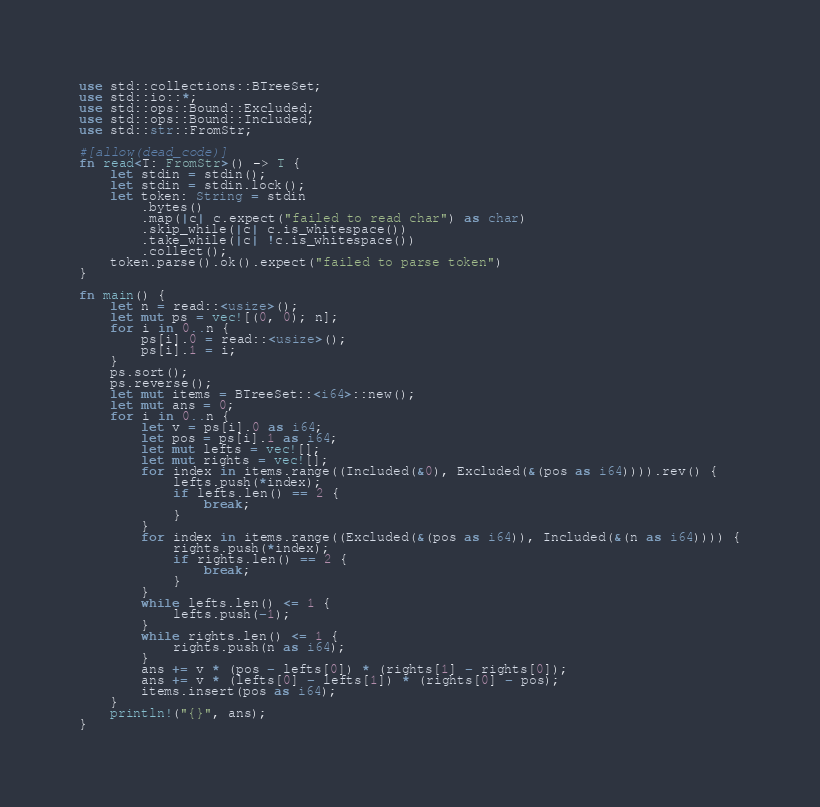Convert code to text. <code><loc_0><loc_0><loc_500><loc_500><_Rust_>use std::collections::BTreeSet;
use std::io::*;
use std::ops::Bound::Excluded;
use std::ops::Bound::Included;
use std::str::FromStr;

#[allow(dead_code)]
fn read<T: FromStr>() -> T {
    let stdin = stdin();
    let stdin = stdin.lock();
    let token: String = stdin
        .bytes()
        .map(|c| c.expect("failed to read char") as char)
        .skip_while(|c| c.is_whitespace())
        .take_while(|c| !c.is_whitespace())
        .collect();
    token.parse().ok().expect("failed to parse token")
}

fn main() {
    let n = read::<usize>();
    let mut ps = vec![(0, 0); n];
    for i in 0..n {
        ps[i].0 = read::<usize>();
        ps[i].1 = i;
    }
    ps.sort();
    ps.reverse();
    let mut items = BTreeSet::<i64>::new();
    let mut ans = 0;
    for i in 0..n {
        let v = ps[i].0 as i64;
        let pos = ps[i].1 as i64;
        let mut lefts = vec![];
        let mut rights = vec![];
        for index in items.range((Included(&0), Excluded(&(pos as i64)))).rev() {
            lefts.push(*index);
            if lefts.len() == 2 {
                break;
            }
        }
        for index in items.range((Excluded(&(pos as i64)), Included(&(n as i64)))) {
            rights.push(*index);
            if rights.len() == 2 {
                break;
            }
        }
        while lefts.len() <= 1 {
            lefts.push(-1);
        }
        while rights.len() <= 1 {
            rights.push(n as i64);
        }
        ans += v * (pos - lefts[0]) * (rights[1] - rights[0]);
        ans += v * (lefts[0] - lefts[1]) * (rights[0] - pos);
        items.insert(pos as i64);
    }
    println!("{}", ans);
}
</code> 